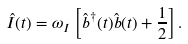Convert formula to latex. <formula><loc_0><loc_0><loc_500><loc_500>\hat { I } ( t ) = \omega _ { I } \left [ \hat { b } ^ { \dagger } ( t ) \hat { b } ( t ) + \frac { 1 } { 2 } \right ] .</formula> 